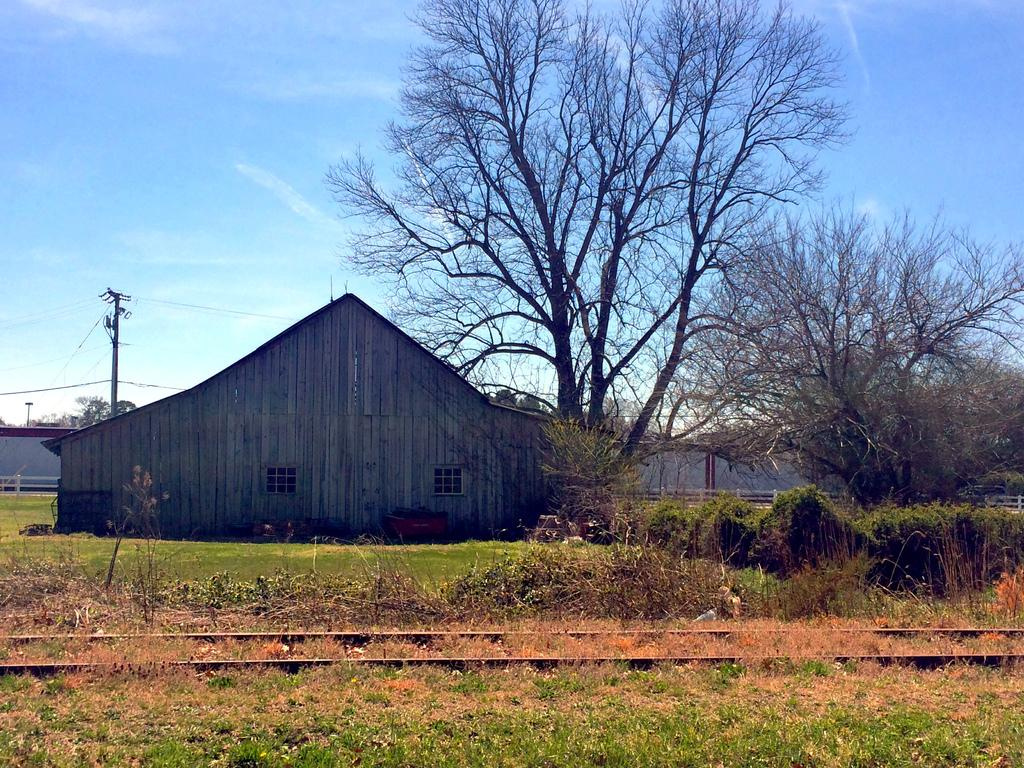What type of landscape is depicted in the image? There is a grassland in the image. What feature can be seen on the grassland? There is a track on the grassland. What can be seen in the background of the image? There are trees, houses, a pole, and the sky visible in the background of the image. What type of knot is being tied by the tree in the image? There is no knot being tied by a tree in the image; trees are not capable of tying knots. 